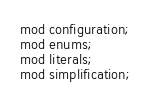Convert code to text. <code><loc_0><loc_0><loc_500><loc_500><_Rust_>mod configuration;
mod enums;
mod literals;
mod simplification;
</code> 